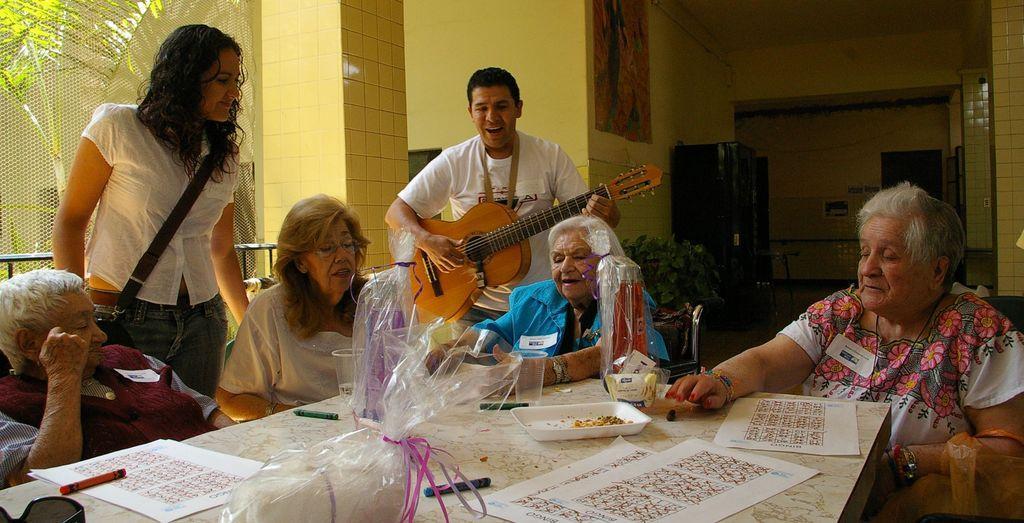Can you describe this image briefly? This image is clicked in a house. There are six members in this image. Four are sitting and two are standing. The man in the middle, is standing and playing guitar. To the left, the person is wearing red color jacket and sitting in a chair. To the right, the woman is sitting in a chair and seeing towards the table. In the middle there is a table, on which plates and papers are kept. In the background, there is a wall photo frame and plants. 